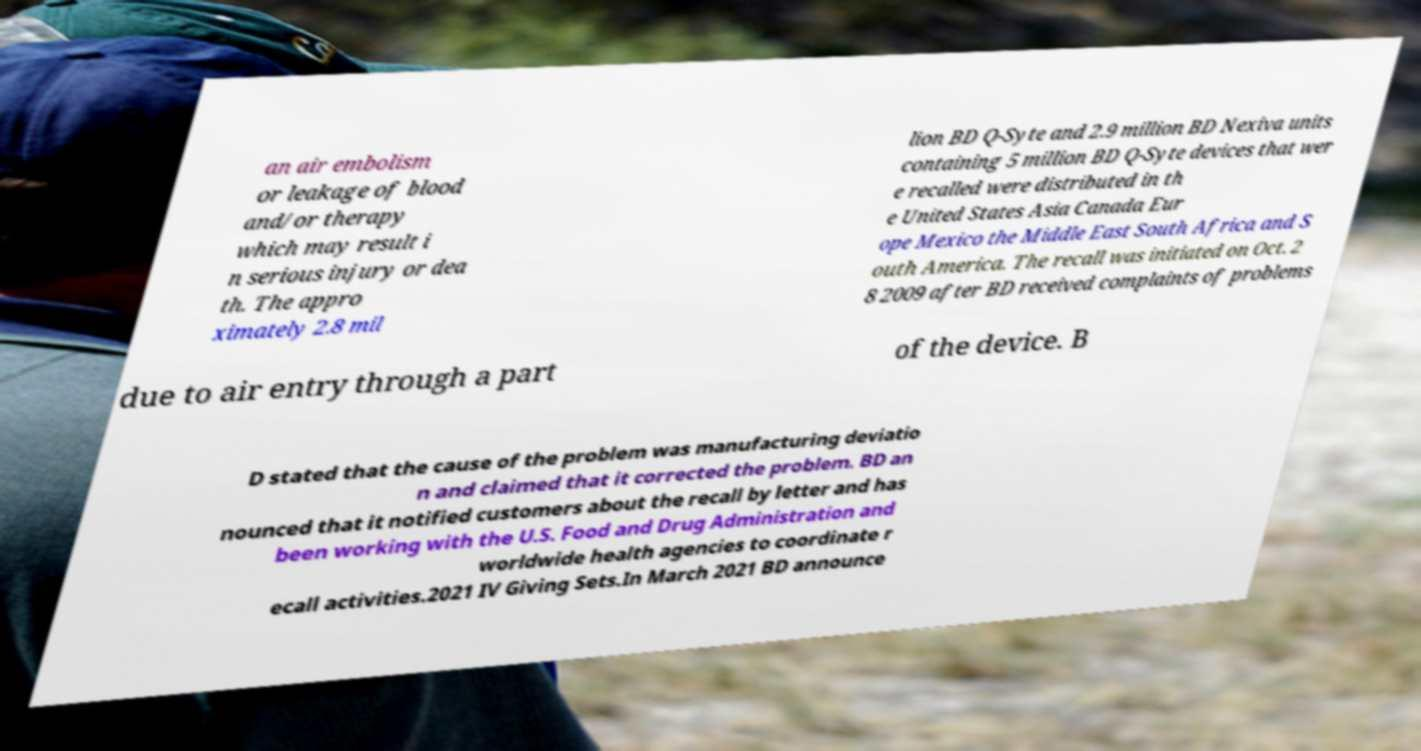Please read and relay the text visible in this image. What does it say? an air embolism or leakage of blood and/or therapy which may result i n serious injury or dea th. The appro ximately 2.8 mil lion BD Q-Syte and 2.9 million BD Nexiva units containing 5 million BD Q-Syte devices that wer e recalled were distributed in th e United States Asia Canada Eur ope Mexico the Middle East South Africa and S outh America. The recall was initiated on Oct. 2 8 2009 after BD received complaints of problems due to air entry through a part of the device. B D stated that the cause of the problem was manufacturing deviatio n and claimed that it corrected the problem. BD an nounced that it notified customers about the recall by letter and has been working with the U.S. Food and Drug Administration and worldwide health agencies to coordinate r ecall activities.2021 IV Giving Sets.In March 2021 BD announce 